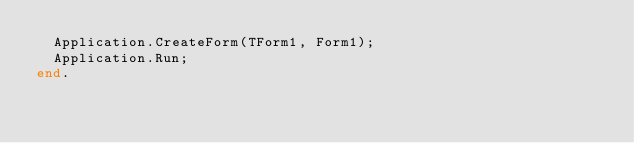<code> <loc_0><loc_0><loc_500><loc_500><_Pascal_>  Application.CreateForm(TForm1, Form1);
  Application.Run;
end.
</code> 